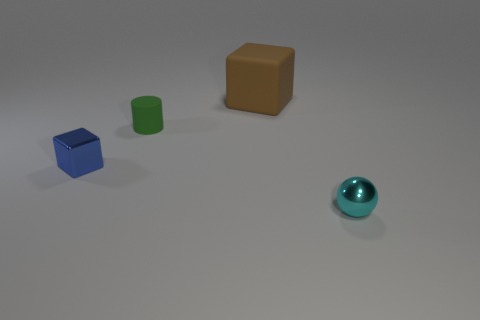Do the small object right of the large thing and the small green rubber object have the same shape?
Provide a short and direct response. No. What is the shape of the tiny green thing?
Make the answer very short. Cylinder. How many balls have the same material as the small cube?
Your response must be concise. 1. There is a small cylinder; does it have the same color as the tiny metallic thing that is left of the small cyan sphere?
Make the answer very short. No. What number of tiny blue matte spheres are there?
Your answer should be compact. 0. Is there a tiny cube of the same color as the large rubber thing?
Make the answer very short. No. There is a metal thing that is left of the big matte block that is right of the tiny metal object left of the green matte thing; what is its color?
Provide a succinct answer. Blue. Are the green cylinder and the block behind the tiny blue metal block made of the same material?
Offer a terse response. Yes. What material is the green object?
Provide a short and direct response. Rubber. What number of other objects are there of the same material as the brown cube?
Your response must be concise. 1. 